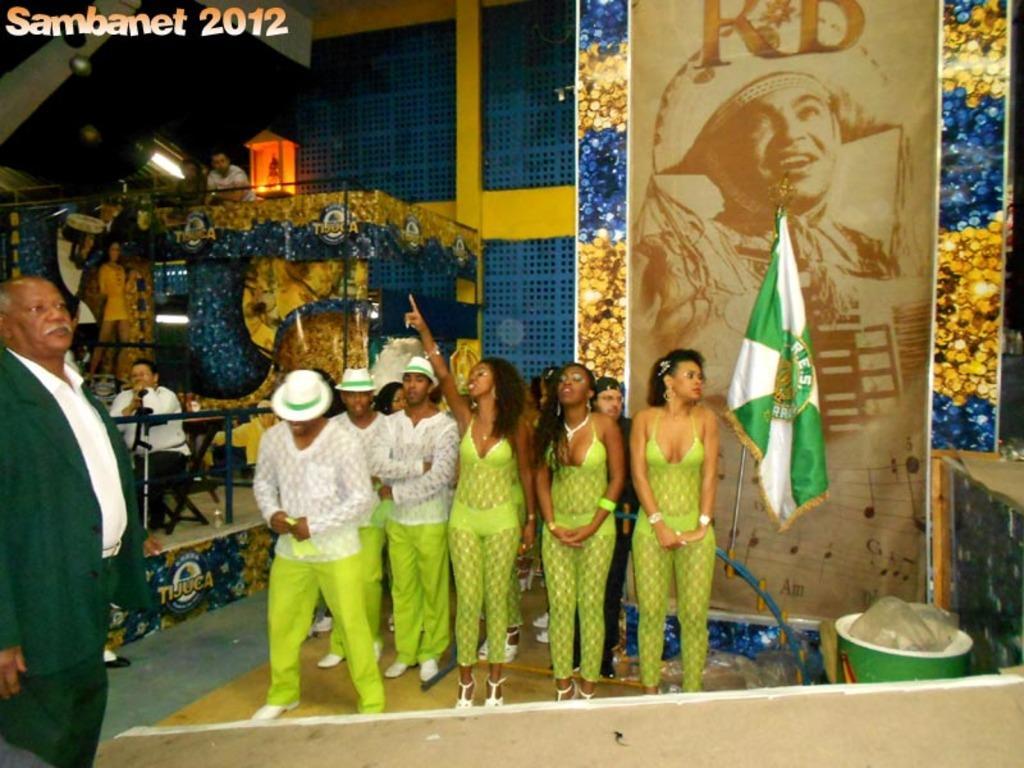Describe this image in one or two sentences. In this image we can see few people standing on the floor, on the right side of the image there is a banner, flag and a trash bin, on the left side of the image there is a light to the ceiling and an object which looks like a lamp. 